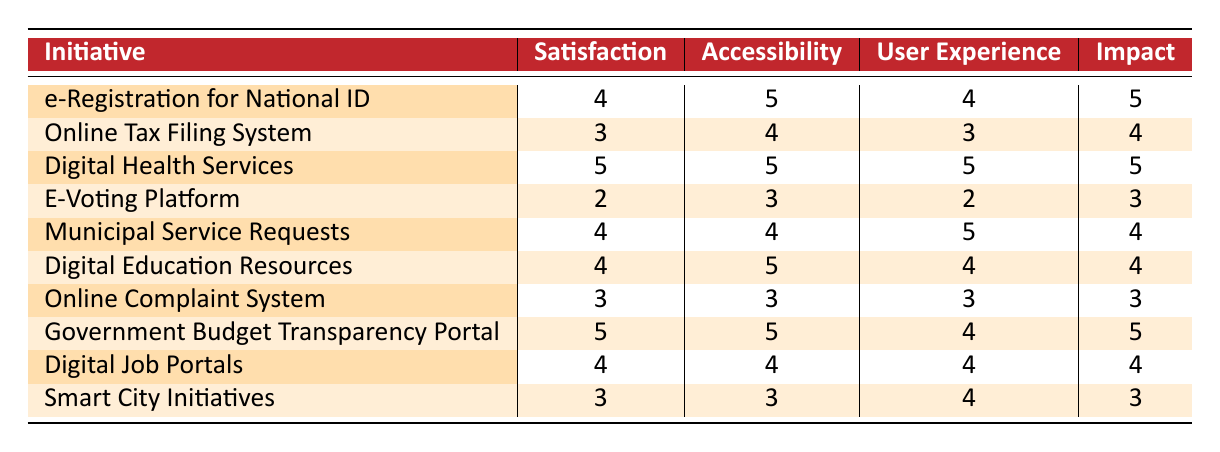What is the satisfaction rating for the Digital Health Services initiative? The table lists Digital Health Services with a satisfaction rating of 5.
Answer: 5 Which initiative has the highest accessibility rating? Digital Health Services and Government Budget Transparency Portal both have the highest accessibility rating of 5.
Answer: Digital Health Services and Government Budget Transparency Portal What is the average satisfaction rating of all initiatives? The total satisfaction ratings are (4 + 3 + 5 + 2 + 4 + 4 + 3 + 5 + 4 + 3) = 43. There are 10 initiatives, so the average is 43/10 = 4.3.
Answer: 4.3 Is the satisfaction rating of the E-Voting Platform greater than the Online Tax Filing System? The satisfaction rating for E-Voting Platform is 2 and for Online Tax Filing System is 3. So, 2 is not greater than 3.
Answer: No Which initiative has a user experience rating of 5? The table shows that Digital Health Services and Municipal Service Requests have a user experience rating of 5.
Answer: Digital Health Services and Municipal Service Requests What is the difference between the most and least satisfied initiatives based on the satisfaction rating? The highest satisfaction rating is 5 (Digital Health Services and Government Budget Transparency Portal) and the lowest is 2 (E-Voting Platform). The difference is 5 - 2 = 3.
Answer: 3 Is the Government Budget Transparency Portal rated higher in user experience than the Smart City Initiatives? The Government Budget Transparency Portal has a user experience rating of 4 while Smart City Initiatives has a user experience rating of 4 as well. Therefore, they are equal.
Answer: No Which initiatives have both a satisfaction rating and impact on citizens of 4 or higher? The initiatives that meet this criterion are e-Registration for National ID, Digital Health Services, Municipal Service Requests, Digital Education Resources, Government Budget Transparency Portal, and Digital Job Portals.
Answer: e-Registration for National ID, Digital Health Services, Municipal Service Requests, Digital Education Resources, Government Budget Transparency Portal, and Digital Job Portals How many initiatives have a satisfaction rating of 3 or lower? The initiatives with a satisfaction rating of 3 or lower are Online Tax Filing System (3), E-Voting Platform (2), and Online Complaint System (3), totaling 3 initiatives.
Answer: 3 